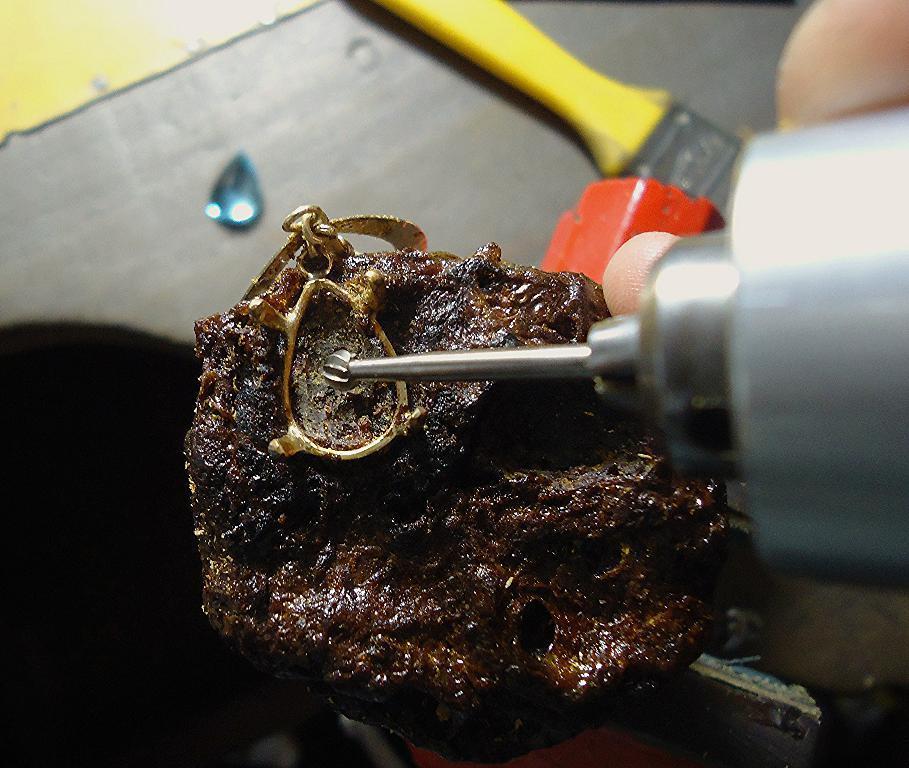In one or two sentences, can you explain what this image depicts? In this image I can see an object in a person's hand. Here I can see a brush and other objects. 